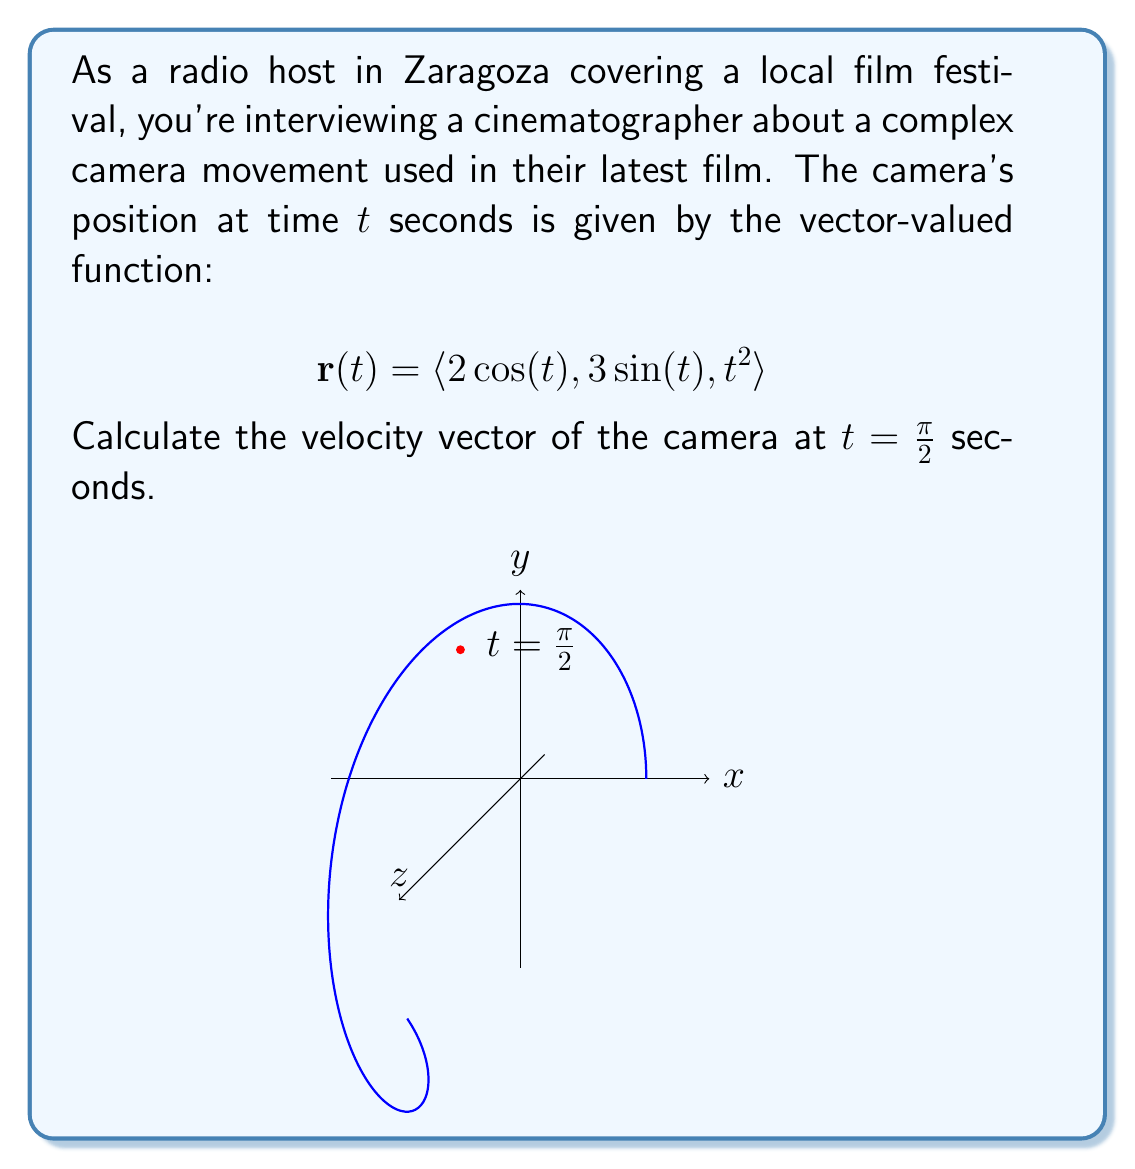Show me your answer to this math problem. To find the velocity vector at $t = \frac{\pi}{2}$, we need to follow these steps:

1) The velocity vector is the derivative of the position vector with respect to time:
   $$\mathbf{v}(t) = \frac{d}{dt}\mathbf{r}(t)$$

2) Let's differentiate each component of $\mathbf{r}(t)$:
   $$\frac{d}{dt}(2\cos(t)) = -2\sin(t)$$
   $$\frac{d}{dt}(3\sin(t)) = 3\cos(t)$$
   $$\frac{d}{dt}(t^2) = 2t$$

3) Therefore, the velocity vector function is:
   $$\mathbf{v}(t) = \langle -2\sin(t), 3\cos(t), 2t \rangle$$

4) Now, we need to evaluate this at $t = \frac{\pi}{2}$:
   $$\mathbf{v}(\frac{\pi}{2}) = \langle -2\sin(\frac{\pi}{2}), 3\cos(\frac{\pi}{2}), 2(\frac{\pi}{2}) \rangle$$

5) Simplify:
   $$\sin(\frac{\pi}{2}) = 1$$
   $$\cos(\frac{\pi}{2}) = 0$$

6) Substituting these values:
   $$\mathbf{v}(\frac{\pi}{2}) = \langle -2(1), 3(0), 2(\frac{\pi}{2}) \rangle = \langle -2, 0, \pi \rangle$$
Answer: $\langle -2, 0, \pi \rangle$ 